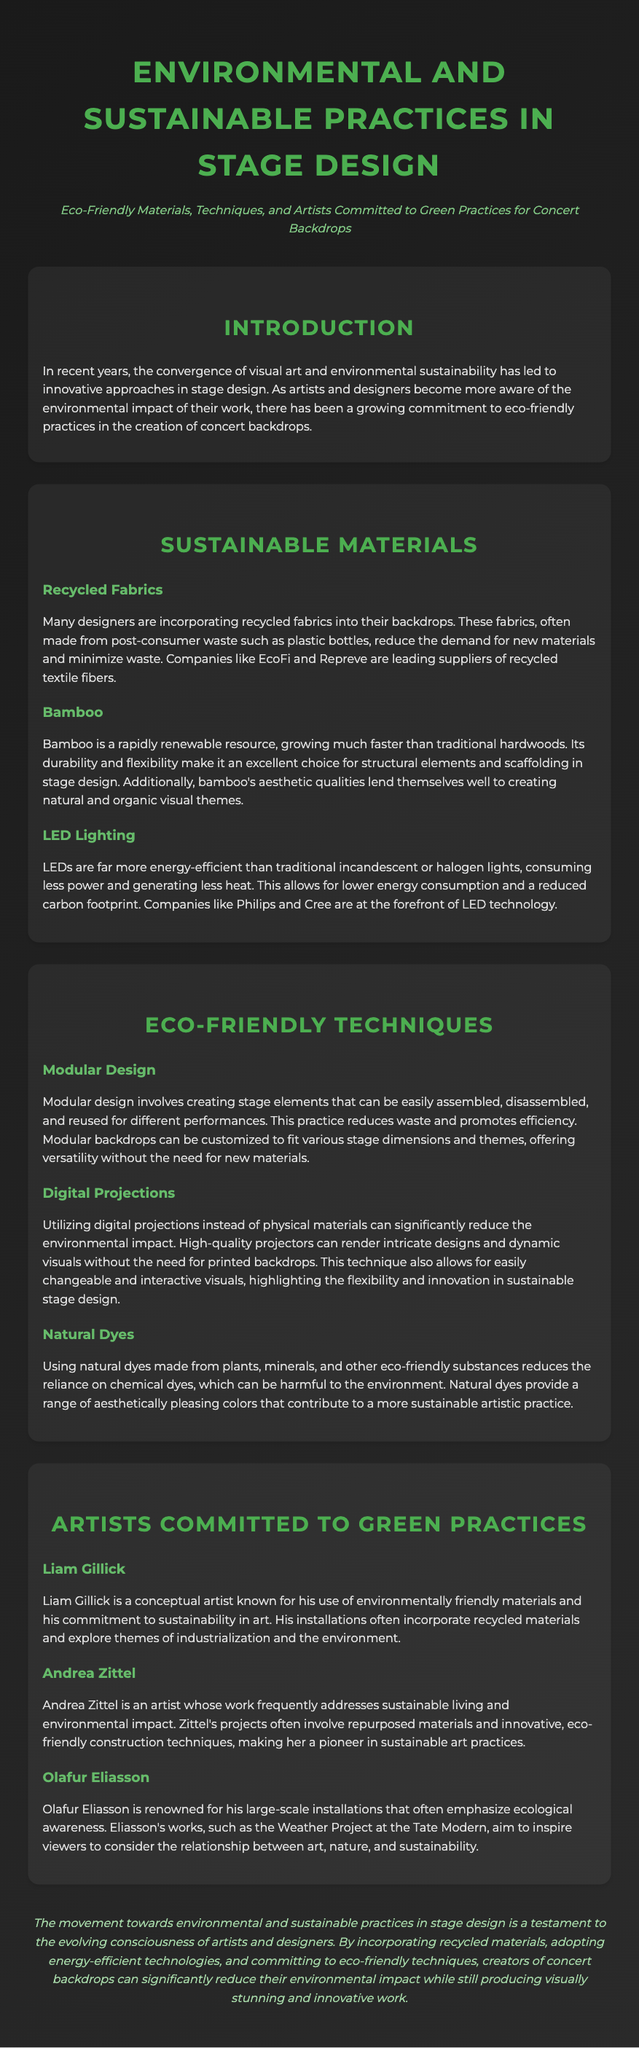What are recycled fabrics made from? The document states that recycled fabrics are often made from post-consumer waste such as plastic bottles.
Answer: plastic bottles Which material is described as a rapidly renewable resource? The section on sustainable materials indicates that bamboo is a rapidly renewable resource.
Answer: bamboo Name one company that leads in recycled textile fibers. The document mentions EcoFi and Repreve as leading suppliers of recycled textile fibers.
Answer: EcoFi What technique helps to reduce waste through reusable stage elements? The document describes modular design as a technique that reduces waste and promotes efficiency.
Answer: modular design Which artist is known for using environmentally friendly materials? Liam Gillick is identified as a conceptual artist known for his use of environmentally friendly materials.
Answer: Liam Gillick What color do natural dyes provide? Natural dyes provide a range of aesthetically pleasing colors.
Answer: aesthetically pleasing colors Name a benefit of using LED lighting mentioned in the document. The document highlights that LEDs consume less power and generate less heat.
Answer: consume less power Which artist is recognized for emphasizing ecological awareness? Olafur Eliasson is recognized for his installations that emphasize ecological awareness.
Answer: Olafur Eliasson What aspect of stage design does digital projection significantly reduce? The document states that digital projections significantly reduce the environmental impact.
Answer: environmental impact 